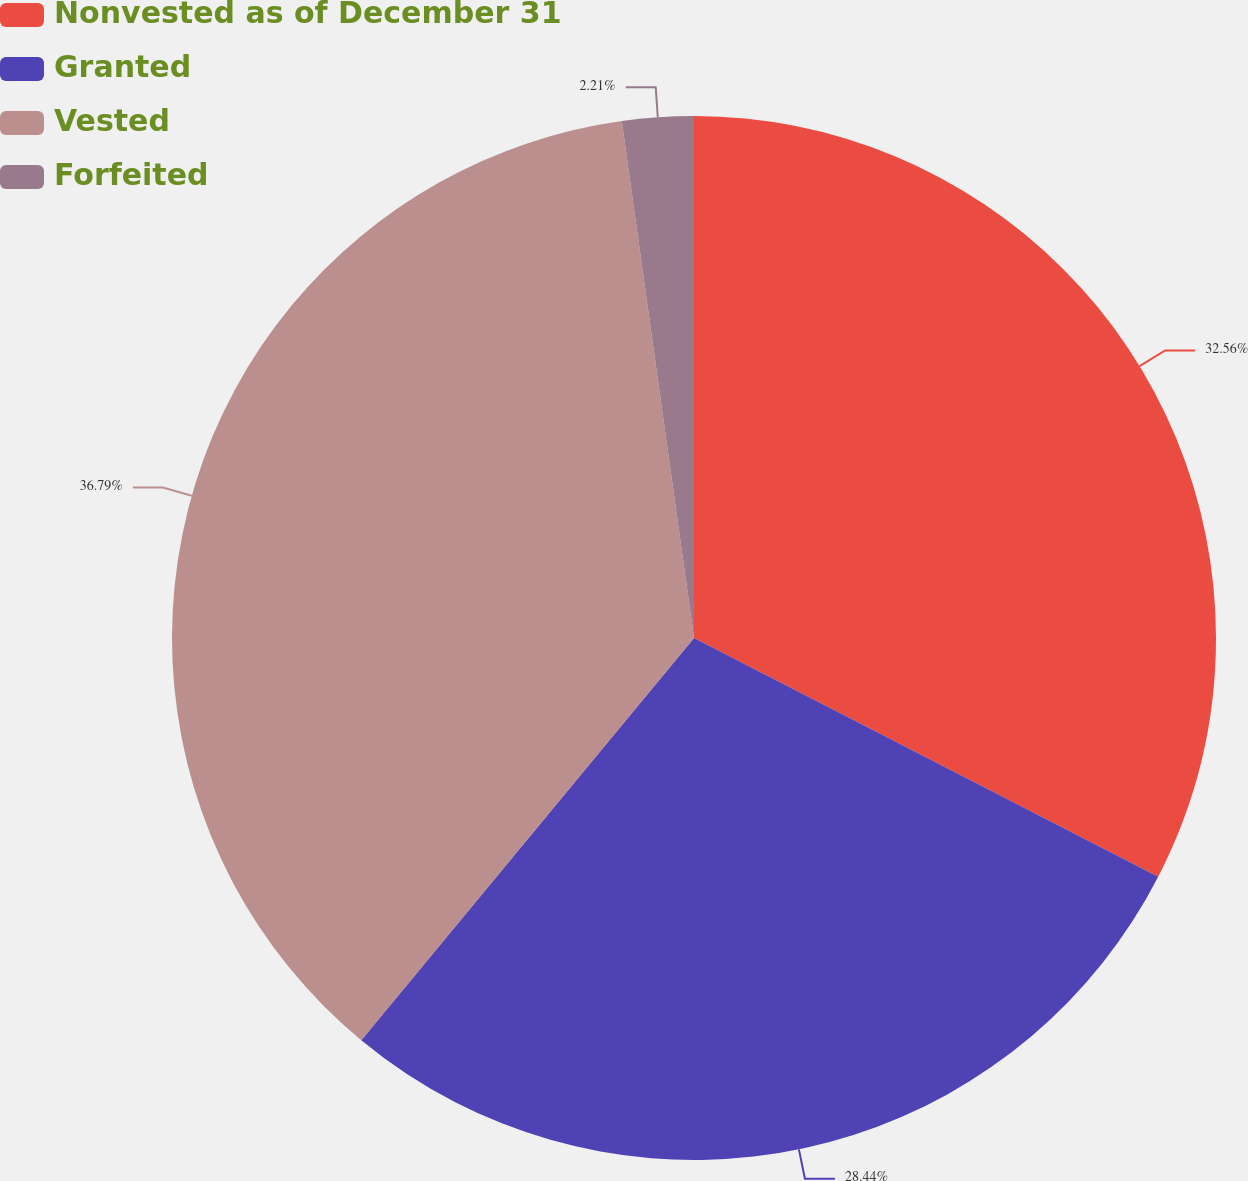Convert chart to OTSL. <chart><loc_0><loc_0><loc_500><loc_500><pie_chart><fcel>Nonvested as of December 31<fcel>Granted<fcel>Vested<fcel>Forfeited<nl><fcel>32.56%<fcel>28.44%<fcel>36.79%<fcel>2.21%<nl></chart> 